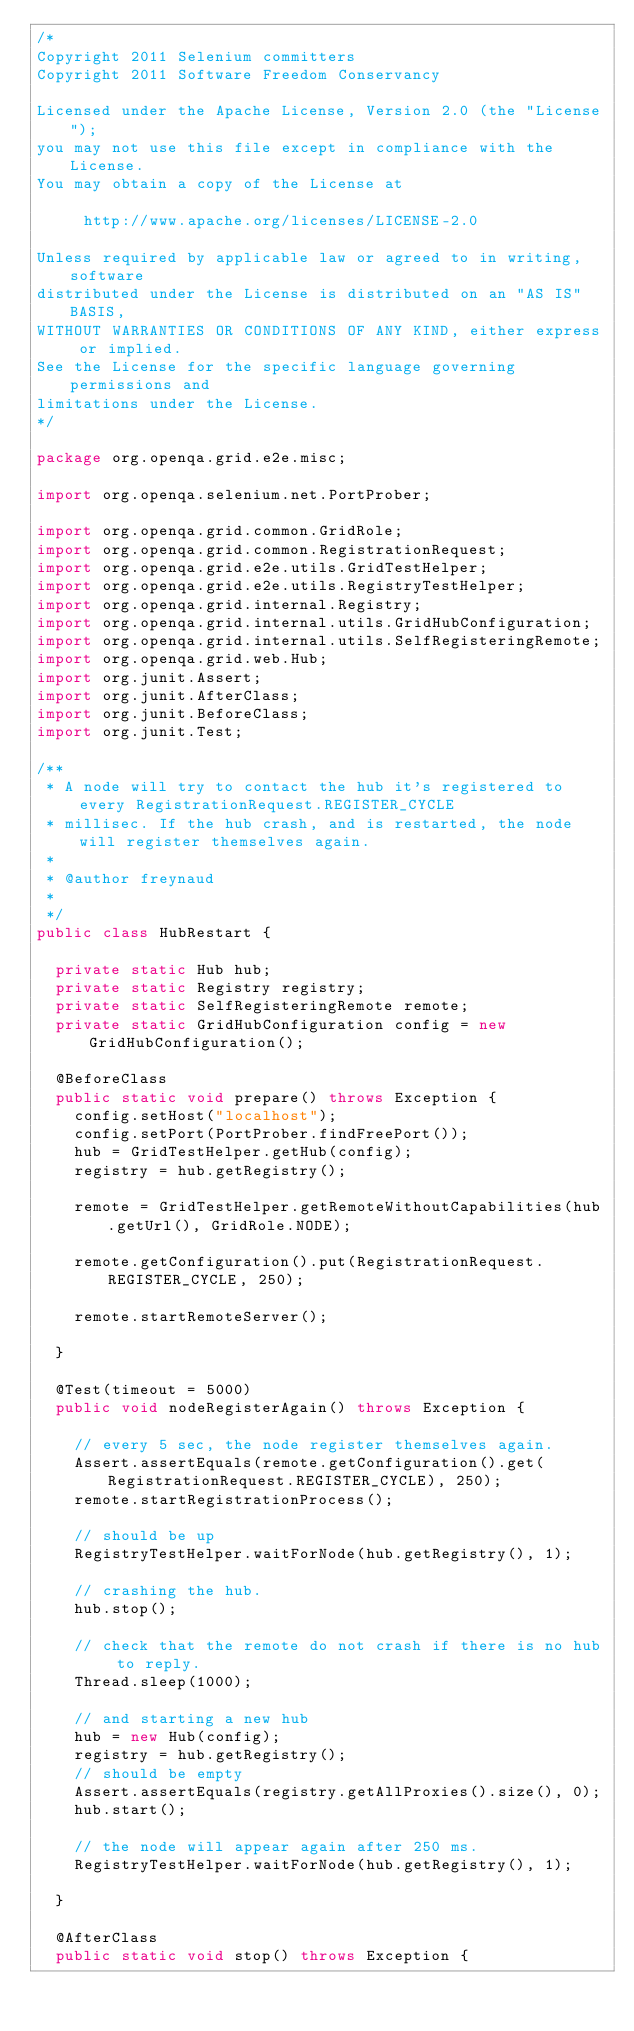Convert code to text. <code><loc_0><loc_0><loc_500><loc_500><_Java_>/*
Copyright 2011 Selenium committers
Copyright 2011 Software Freedom Conservancy

Licensed under the Apache License, Version 2.0 (the "License");
you may not use this file except in compliance with the License.
You may obtain a copy of the License at

     http://www.apache.org/licenses/LICENSE-2.0

Unless required by applicable law or agreed to in writing, software
distributed under the License is distributed on an "AS IS" BASIS,
WITHOUT WARRANTIES OR CONDITIONS OF ANY KIND, either express or implied.
See the License for the specific language governing permissions and
limitations under the License.
*/

package org.openqa.grid.e2e.misc;

import org.openqa.selenium.net.PortProber;

import org.openqa.grid.common.GridRole;
import org.openqa.grid.common.RegistrationRequest;
import org.openqa.grid.e2e.utils.GridTestHelper;
import org.openqa.grid.e2e.utils.RegistryTestHelper;
import org.openqa.grid.internal.Registry;
import org.openqa.grid.internal.utils.GridHubConfiguration;
import org.openqa.grid.internal.utils.SelfRegisteringRemote;
import org.openqa.grid.web.Hub;
import org.junit.Assert;
import org.junit.AfterClass;
import org.junit.BeforeClass;
import org.junit.Test;

/**
 * A node will try to contact the hub it's registered to every RegistrationRequest.REGISTER_CYCLE
 * millisec. If the hub crash, and is restarted, the node will register themselves again.
 * 
 * @author freynaud
 * 
 */
public class HubRestart {

  private static Hub hub;
  private static Registry registry;
  private static SelfRegisteringRemote remote;
  private static GridHubConfiguration config = new GridHubConfiguration();

  @BeforeClass
  public static void prepare() throws Exception {
    config.setHost("localhost");
    config.setPort(PortProber.findFreePort());
    hub = GridTestHelper.getHub(config);
    registry = hub.getRegistry();

    remote = GridTestHelper.getRemoteWithoutCapabilities(hub.getUrl(), GridRole.NODE);

    remote.getConfiguration().put(RegistrationRequest.REGISTER_CYCLE, 250);

    remote.startRemoteServer();

  }

  @Test(timeout = 5000)
  public void nodeRegisterAgain() throws Exception {

    // every 5 sec, the node register themselves again.
    Assert.assertEquals(remote.getConfiguration().get(RegistrationRequest.REGISTER_CYCLE), 250);
    remote.startRegistrationProcess();

    // should be up
    RegistryTestHelper.waitForNode(hub.getRegistry(), 1);

    // crashing the hub.
    hub.stop();

    // check that the remote do not crash if there is no hub to reply.
    Thread.sleep(1000);

    // and starting a new hub
    hub = new Hub(config);
    registry = hub.getRegistry();
    // should be empty
    Assert.assertEquals(registry.getAllProxies().size(), 0);
    hub.start();

    // the node will appear again after 250 ms.
    RegistryTestHelper.waitForNode(hub.getRegistry(), 1);

  }

  @AfterClass
  public static void stop() throws Exception {</code> 